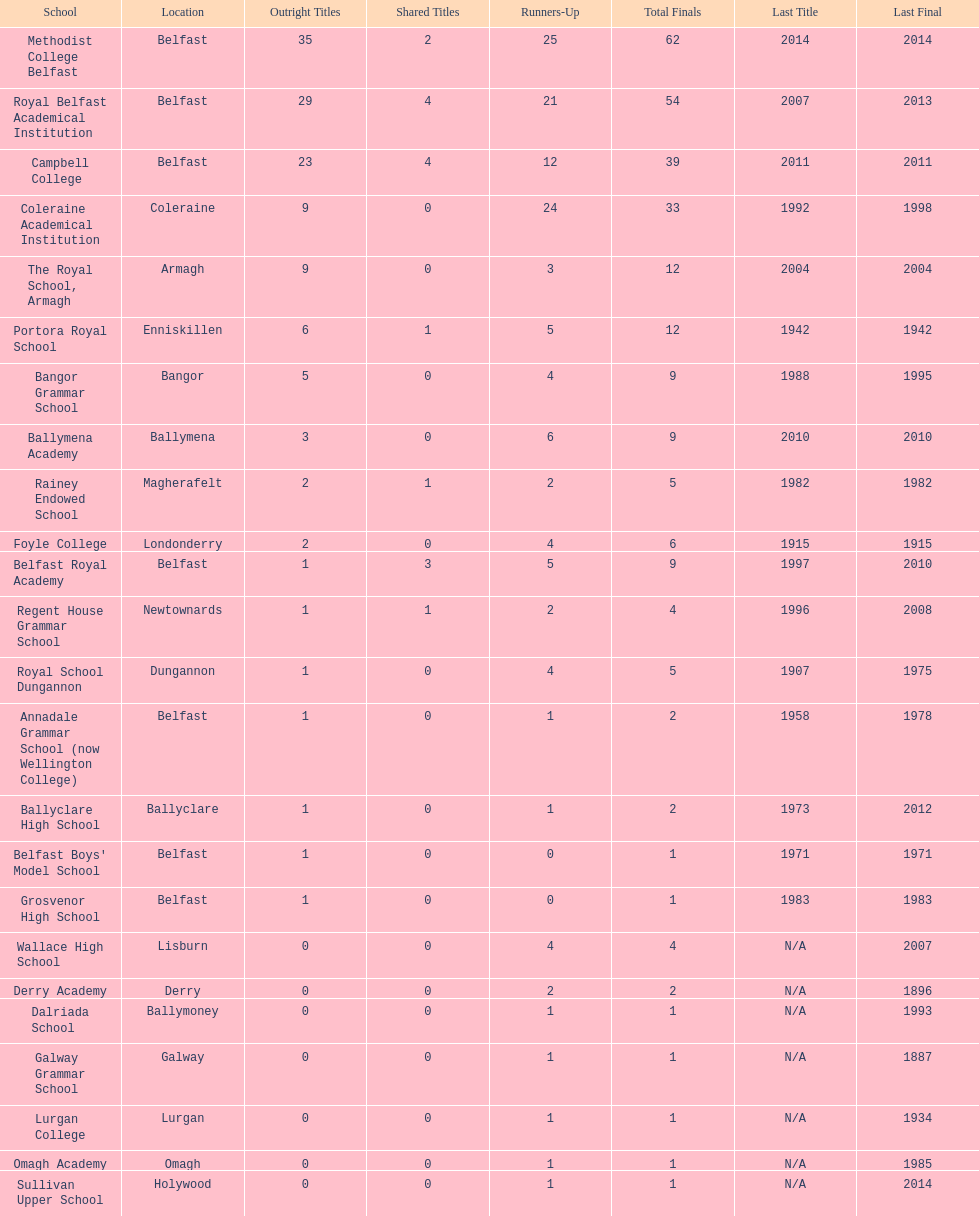What is the number of schools that hold a minimum of 5 undisputed championships? 7. 